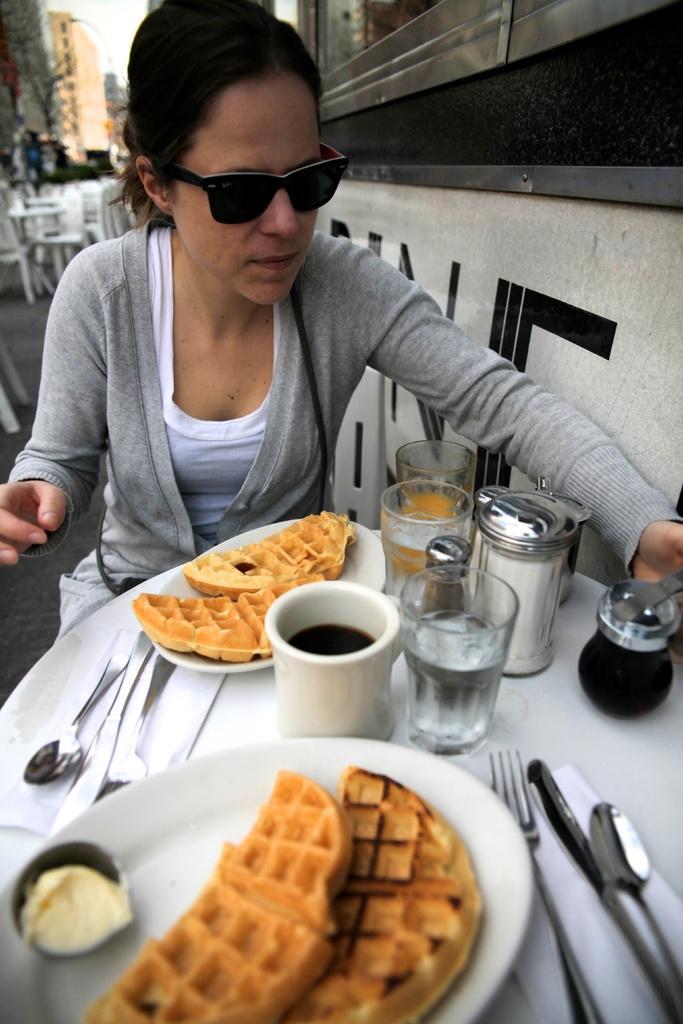How would you summarize this image in a sentence or two? In this picture there is a woman sitting beside the table. She is wearing a grey jacket and white t shirt. On the table, there were two plates of waffles, glasses, jars, forks and spoons were placed on the table. In the background there are chairs and tables. Towards the right there is a wall. 